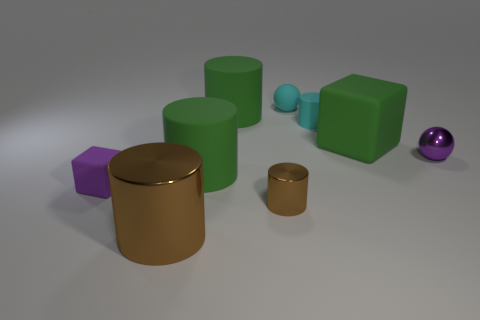How many other things are the same shape as the large brown thing?
Provide a short and direct response. 4. The ball behind the tiny matte cylinder that is in front of the tiny cyan matte ball behind the cyan rubber cylinder is what color?
Keep it short and to the point. Cyan. How many small purple spheres are there?
Offer a terse response. 1. How many small objects are either cyan matte cylinders or cyan rubber balls?
Offer a terse response. 2. What shape is the purple rubber thing that is the same size as the cyan sphere?
Provide a short and direct response. Cube. Is there anything else that has the same size as the cyan cylinder?
Offer a very short reply. Yes. What is the tiny cylinder that is in front of the cube that is left of the big brown object made of?
Your answer should be very brief. Metal. Do the purple shiny thing and the cyan rubber ball have the same size?
Give a very brief answer. Yes. How many things are big green objects on the right side of the cyan cylinder or big brown things?
Provide a succinct answer. 2. The purple object in front of the tiny shiny object on the right side of the cyan rubber ball is what shape?
Offer a very short reply. Cube. 